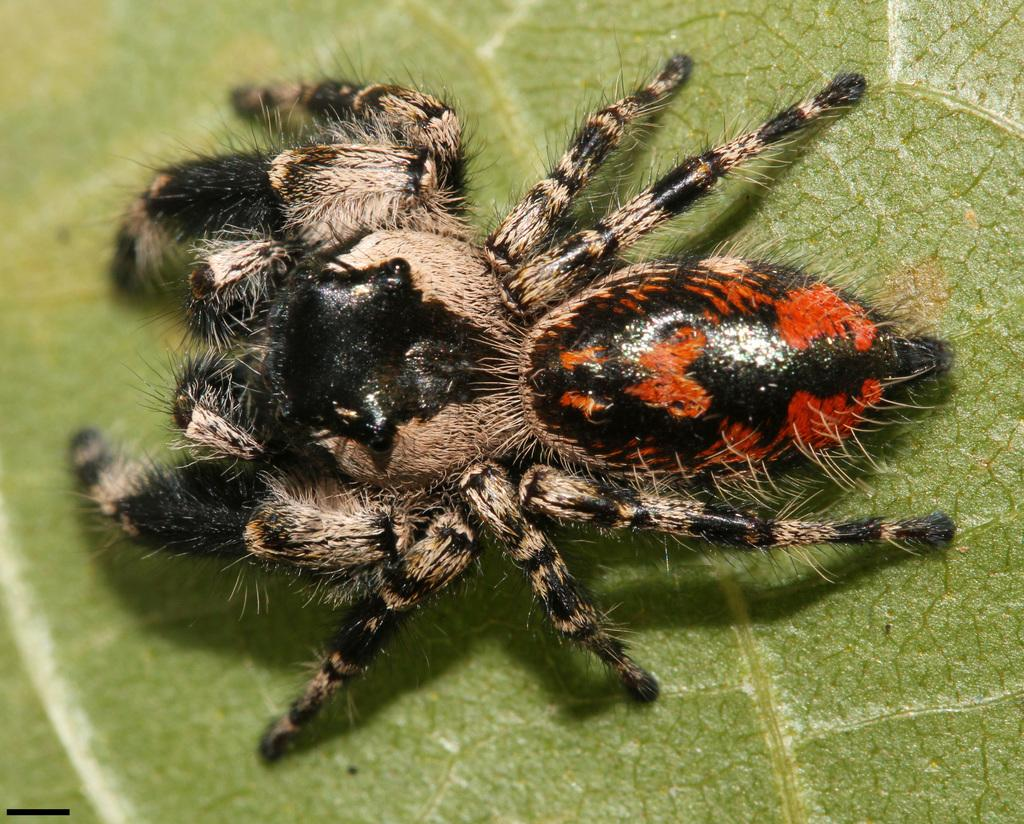What type of creature is in the image? There is an insect in the image. What colors can be seen on the insect? The insect has black, red, and brown colors. Where is the insect located in the image? The insect is on a green leaf. What type of lunch is the insect eating in the image? There is no indication in the image that the insect is eating lunch, as insects typically do not consume human food. 